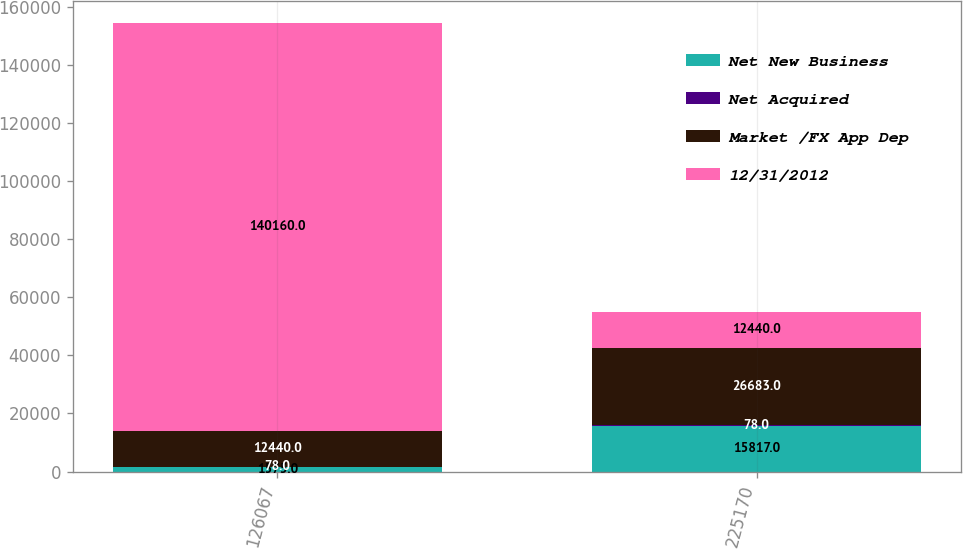<chart> <loc_0><loc_0><loc_500><loc_500><stacked_bar_chart><ecel><fcel>126067<fcel>225170<nl><fcel>Net New Business<fcel>1575<fcel>15817<nl><fcel>Net Acquired<fcel>78<fcel>78<nl><fcel>Market /FX App Dep<fcel>12440<fcel>26683<nl><fcel>12/31/2012<fcel>140160<fcel>12440<nl></chart> 